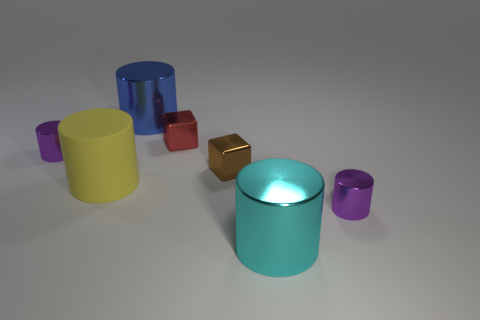Subtract all gray balls. How many purple cylinders are left? 2 Subtract all yellow cylinders. How many cylinders are left? 4 Subtract all purple cylinders. How many cylinders are left? 3 Subtract 1 cylinders. How many cylinders are left? 4 Subtract all brown cylinders. Subtract all red blocks. How many cylinders are left? 5 Add 1 gray matte balls. How many objects exist? 8 Add 5 tiny yellow rubber spheres. How many tiny yellow rubber spheres exist? 5 Subtract 0 blue blocks. How many objects are left? 7 Subtract all cylinders. How many objects are left? 2 Subtract all brown shiny objects. Subtract all cyan shiny objects. How many objects are left? 5 